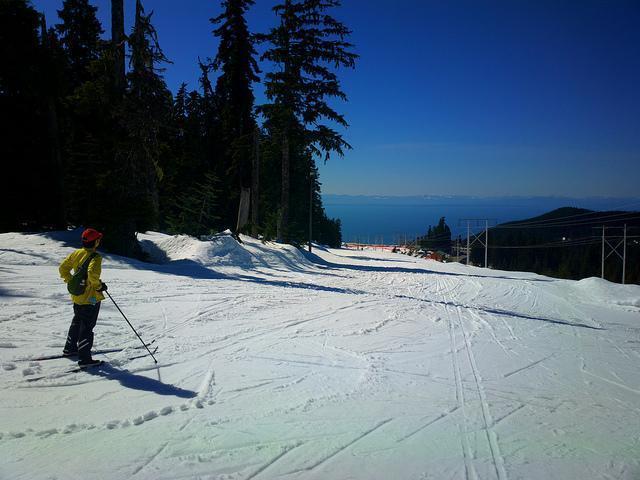How many people are in the picture?
Give a very brief answer. 1. How many levels does this bus have?
Give a very brief answer. 0. 